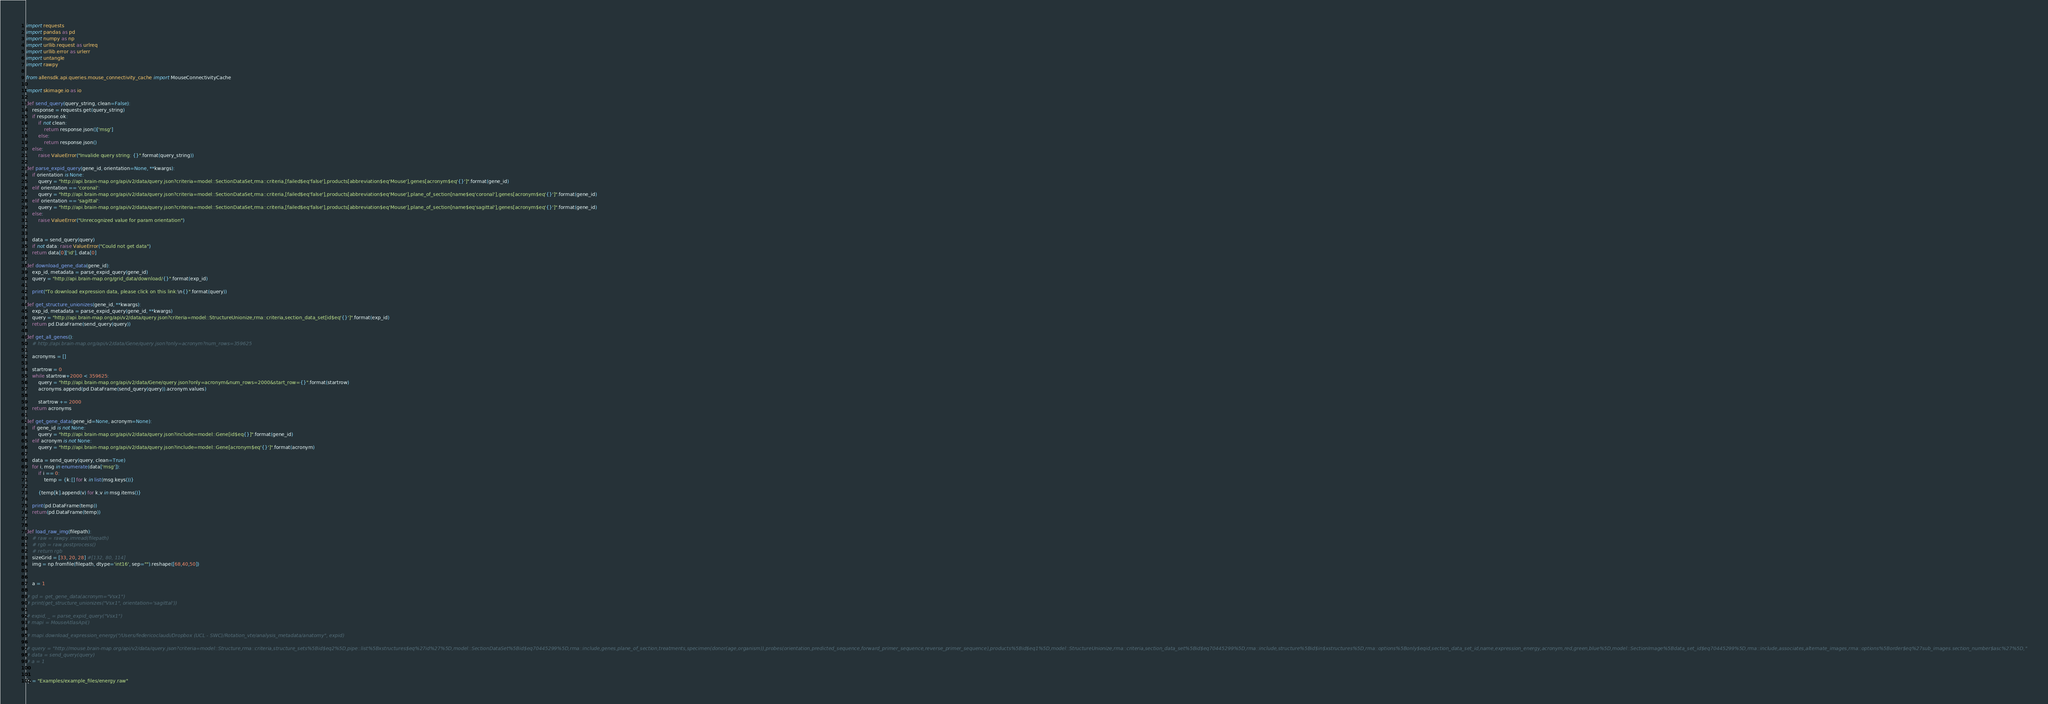<code> <loc_0><loc_0><loc_500><loc_500><_Python_>import requests
import pandas as pd
import numpy as np
import urllib.request as urlreq
import urllib.error as urlerr
import untangle
import rawpy

from allensdk.api.queries.mouse_connectivity_cache import MouseConnectivityCache

import skimage.io as io

def send_query(query_string, clean=False):
	response = requests.get(query_string)
	if response.ok:
		if not clean:
			return response.json()['msg']
		else:
			return response.json()
	else:
		raise ValueError("Invalide query string: {}".format(query_string))

def parse_expid_query(gene_id, orientation=None, **kwargs):
	if orientation is None:
		query = "http://api.brain-map.org/api/v2/data/query.json?criteria=model::SectionDataSet,rma::criteria,[failed$eq'false'],products[abbreviation$eq'Mouse'],genes[acronym$eq'{}']".format(gene_id)	
	elif orientation == 'coronal':
		query = "http://api.brain-map.org/api/v2/data/query.json?criteria=model::SectionDataSet,rma::criteria,[failed$eq'false'],products[abbreviation$eq'Mouse'],plane_of_section[name$eq'coronal'],genes[acronym$eq'{}']".format(gene_id)	
	elif orientation == 'sagittal':
		query = "http://api.brain-map.org/api/v2/data/query.json?criteria=model::SectionDataSet,rma::criteria,[failed$eq'false'],products[abbreviation$eq'Mouse'],plane_of_section[name$eq'sagittal'],genes[acronym$eq'{}']".format(gene_id)	
	else:
		raise ValueError("Unrecognized value for param orientation")


	data = send_query(query)
	if not data: raise ValueError("Could not get data")
	return data[0]['id'], data[0]

def download_gene_data(gene_id):
	exp_id, metadata = parse_expid_query(gene_id)
	query = "http://api.brain-map.org/grid_data/download/{}".format(exp_id)

	print("To download expression data, please click on this link:\n{}".format(query))
	
def get_structure_unionizes(gene_id, **kwargs):
	exp_id, metadata = parse_expid_query(gene_id, **kwargs)
	query = "http://api.brain-map.org/api/v2/data/query.json?criteria=model::StructureUnionize,rma::criteria,section_data_set[id$eq'{}']".format(exp_id)
	return pd.DataFrame(send_query(query))

def get_all_genes():
	# http://api.brain-map.org/api/v2/data/Gene/query.json?only=acronym?num_rows=359625

	acronyms = []

	startrow = 0
	while startrow+2000 < 359625:
		query = "http://api.brain-map.org/api/v2/data/Gene/query.json?only=acronym&num_rows=2000&start_row={}".format(startrow)
		acronyms.append(pd.DataFrame(send_query(query)).acronym.values)

		startrow += 2000
	return acronyms

def get_gene_data(gene_id=None, acronym=None):
	if gene_id is not None:
		query = "http://api.brain-map.org/api/v2/data/query.json?include=model::Gene[id$eq{}]".format(gene_id)
	elif acronym is not None:
		query = "http://api.brain-map.org/api/v2/data/query.json?include=model::Gene[acronym$eq'{}']".format(acronym)

	data = send_query(query, clean=True)
	for i, msg in enumerate(data['msg']):
		if i == 0:
			temp = {k:[] for k in list(msg.keys())}
		
		{temp[k].append(v) for k,v in msg.items()}

	print(pd.DataFrame(temp))
	return(pd.DataFrame(temp))


def load_raw_img(filepath):
	# raw = rawpy.imread(filepath)
	# rgb = raw.postprocess()
	# return rgb
	sizeGrid = [33, 20, 28] #[132, 80, 114]
	img = np.fromfile(filepath, dtype='int16', sep="").reshape([68,40,50])


	a = 1

# gd = get_gene_data(acronym="Vsx1")
# print(get_structure_unionizes("Vsx1", orientation='sagittal'))

# expid, _ = parse_expid_query("Vsx1")
# mapi = MouseAtlasApi()

# mapi.download_expression_energy("/Users/federicoclaudi/Dropbox (UCL - SWC)/Rotation_vte/analysis_metadata/anatomy", expid)

# query = "http://mouse.brain-map.org/api/v2/data/query.json?criteria=model::Structure,rma::criteria,structure_sets%5Bid$eq2%5D,pipe::list%5Bxstructures$eq%27id%27%5D,model::SectionDataSet%5Bid$eq70445299%5D,rma::include,genes,plane_of_section,treatments,specimen(donor(age,organism)),probes(orientation,predicted_sequence,forward_primer_sequence,reverse_primer_sequence),products%5Bid$eq1%5D,model::StructureUnionize,rma::criteria,section_data_set%5Bid$eq70445299%5D,rma::include,structure%5Bid$in$xstructures%5D,rma::options%5Bonly$eqid,section_data_set_id,name,expression_energy,acronym,red,green,blue%5D,model::SectionImage%5Bdata_set_id$eq70445299%5D,rma::include,associates,alternate_images,rma::options%5Border$eq%27sub_images.section_number$asc%27%5D,"
# data = send_query(query)
# a = 1


fp = "Examples/example_files/energy.raw"</code> 